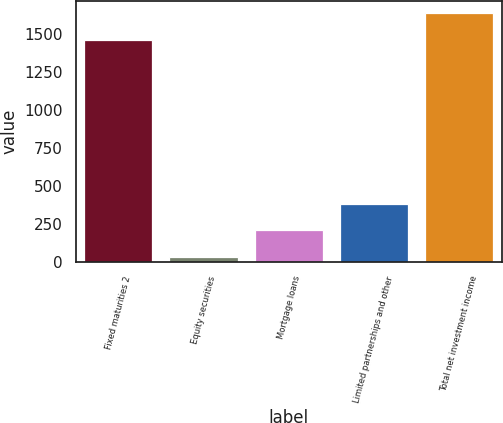<chart> <loc_0><loc_0><loc_500><loc_500><bar_chart><fcel>Fixed maturities 2<fcel>Equity securities<fcel>Mortgage loans<fcel>Limited partnerships and other<fcel>Total net investment income<nl><fcel>1459<fcel>32<fcel>206.8<fcel>381.6<fcel>1633.8<nl></chart> 